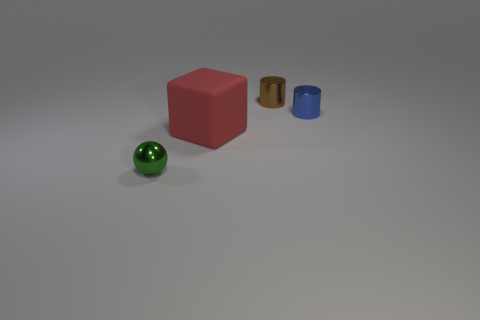Is there anything else that is made of the same material as the red block?
Ensure brevity in your answer.  No. Do the cylinder left of the blue metal thing and the big rubber thing have the same size?
Offer a terse response. No. The small green thing has what shape?
Provide a short and direct response. Sphere. What number of blue things have the same shape as the tiny brown metallic object?
Give a very brief answer. 1. What number of small objects are on the left side of the blue metal cylinder and on the right side of the tiny green metallic object?
Offer a very short reply. 1. The matte cube is what color?
Provide a short and direct response. Red. Is there a big cube that has the same material as the small green thing?
Give a very brief answer. No. Is there a metallic cylinder that is to the left of the tiny cylinder in front of the cylinder that is behind the small blue shiny cylinder?
Ensure brevity in your answer.  Yes. There is a big matte object; are there any brown things in front of it?
Keep it short and to the point. No. Is there another thing of the same color as the rubber object?
Give a very brief answer. No. 